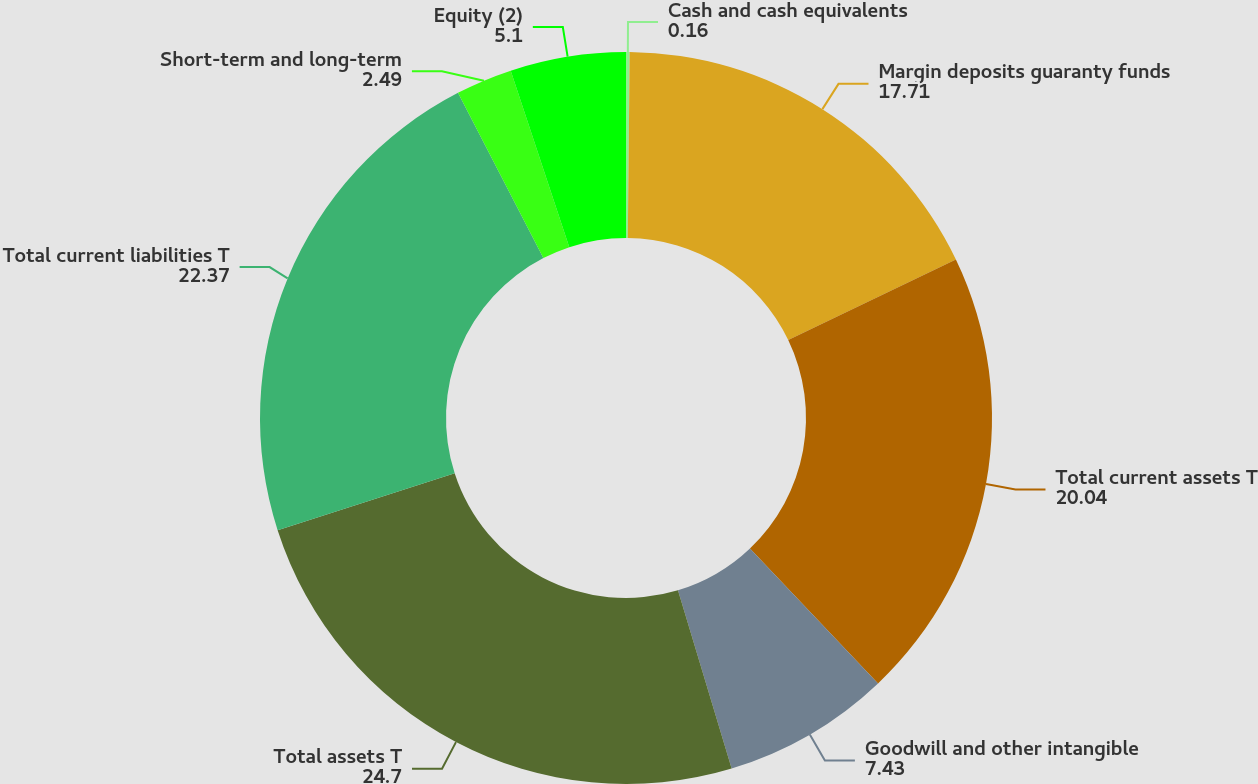Convert chart to OTSL. <chart><loc_0><loc_0><loc_500><loc_500><pie_chart><fcel>Cash and cash equivalents<fcel>Margin deposits guaranty funds<fcel>Total current assets T<fcel>Goodwill and other intangible<fcel>Total assets T<fcel>Total current liabilities T<fcel>Short-term and long-term<fcel>Equity (2)<nl><fcel>0.16%<fcel>17.71%<fcel>20.04%<fcel>7.43%<fcel>24.7%<fcel>22.37%<fcel>2.49%<fcel>5.1%<nl></chart> 